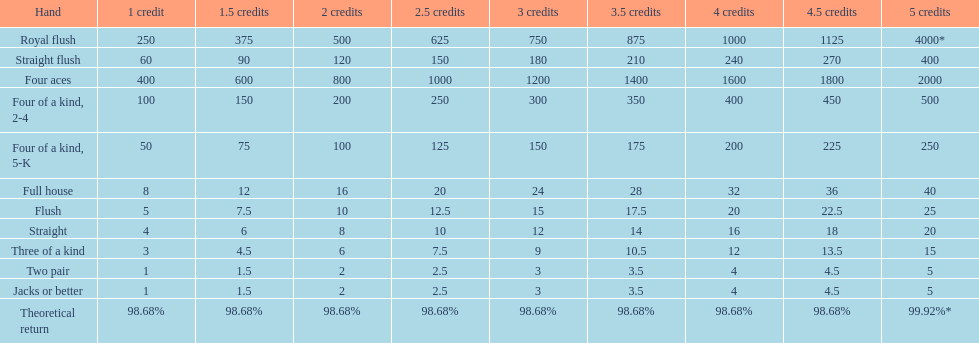The number of flush wins at one credit to equal one flush win at 5 credits. 5. 